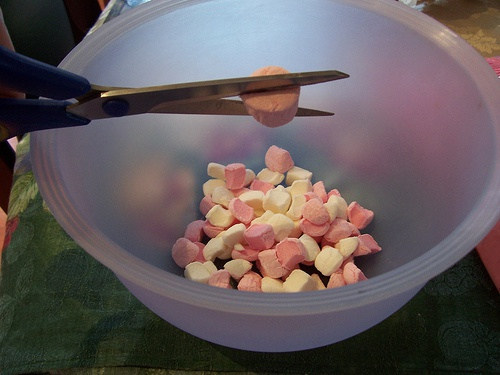Describe the objects in this image and their specific colors. I can see bowl in black, gray, and darkgray tones and scissors in black, maroon, and brown tones in this image. 